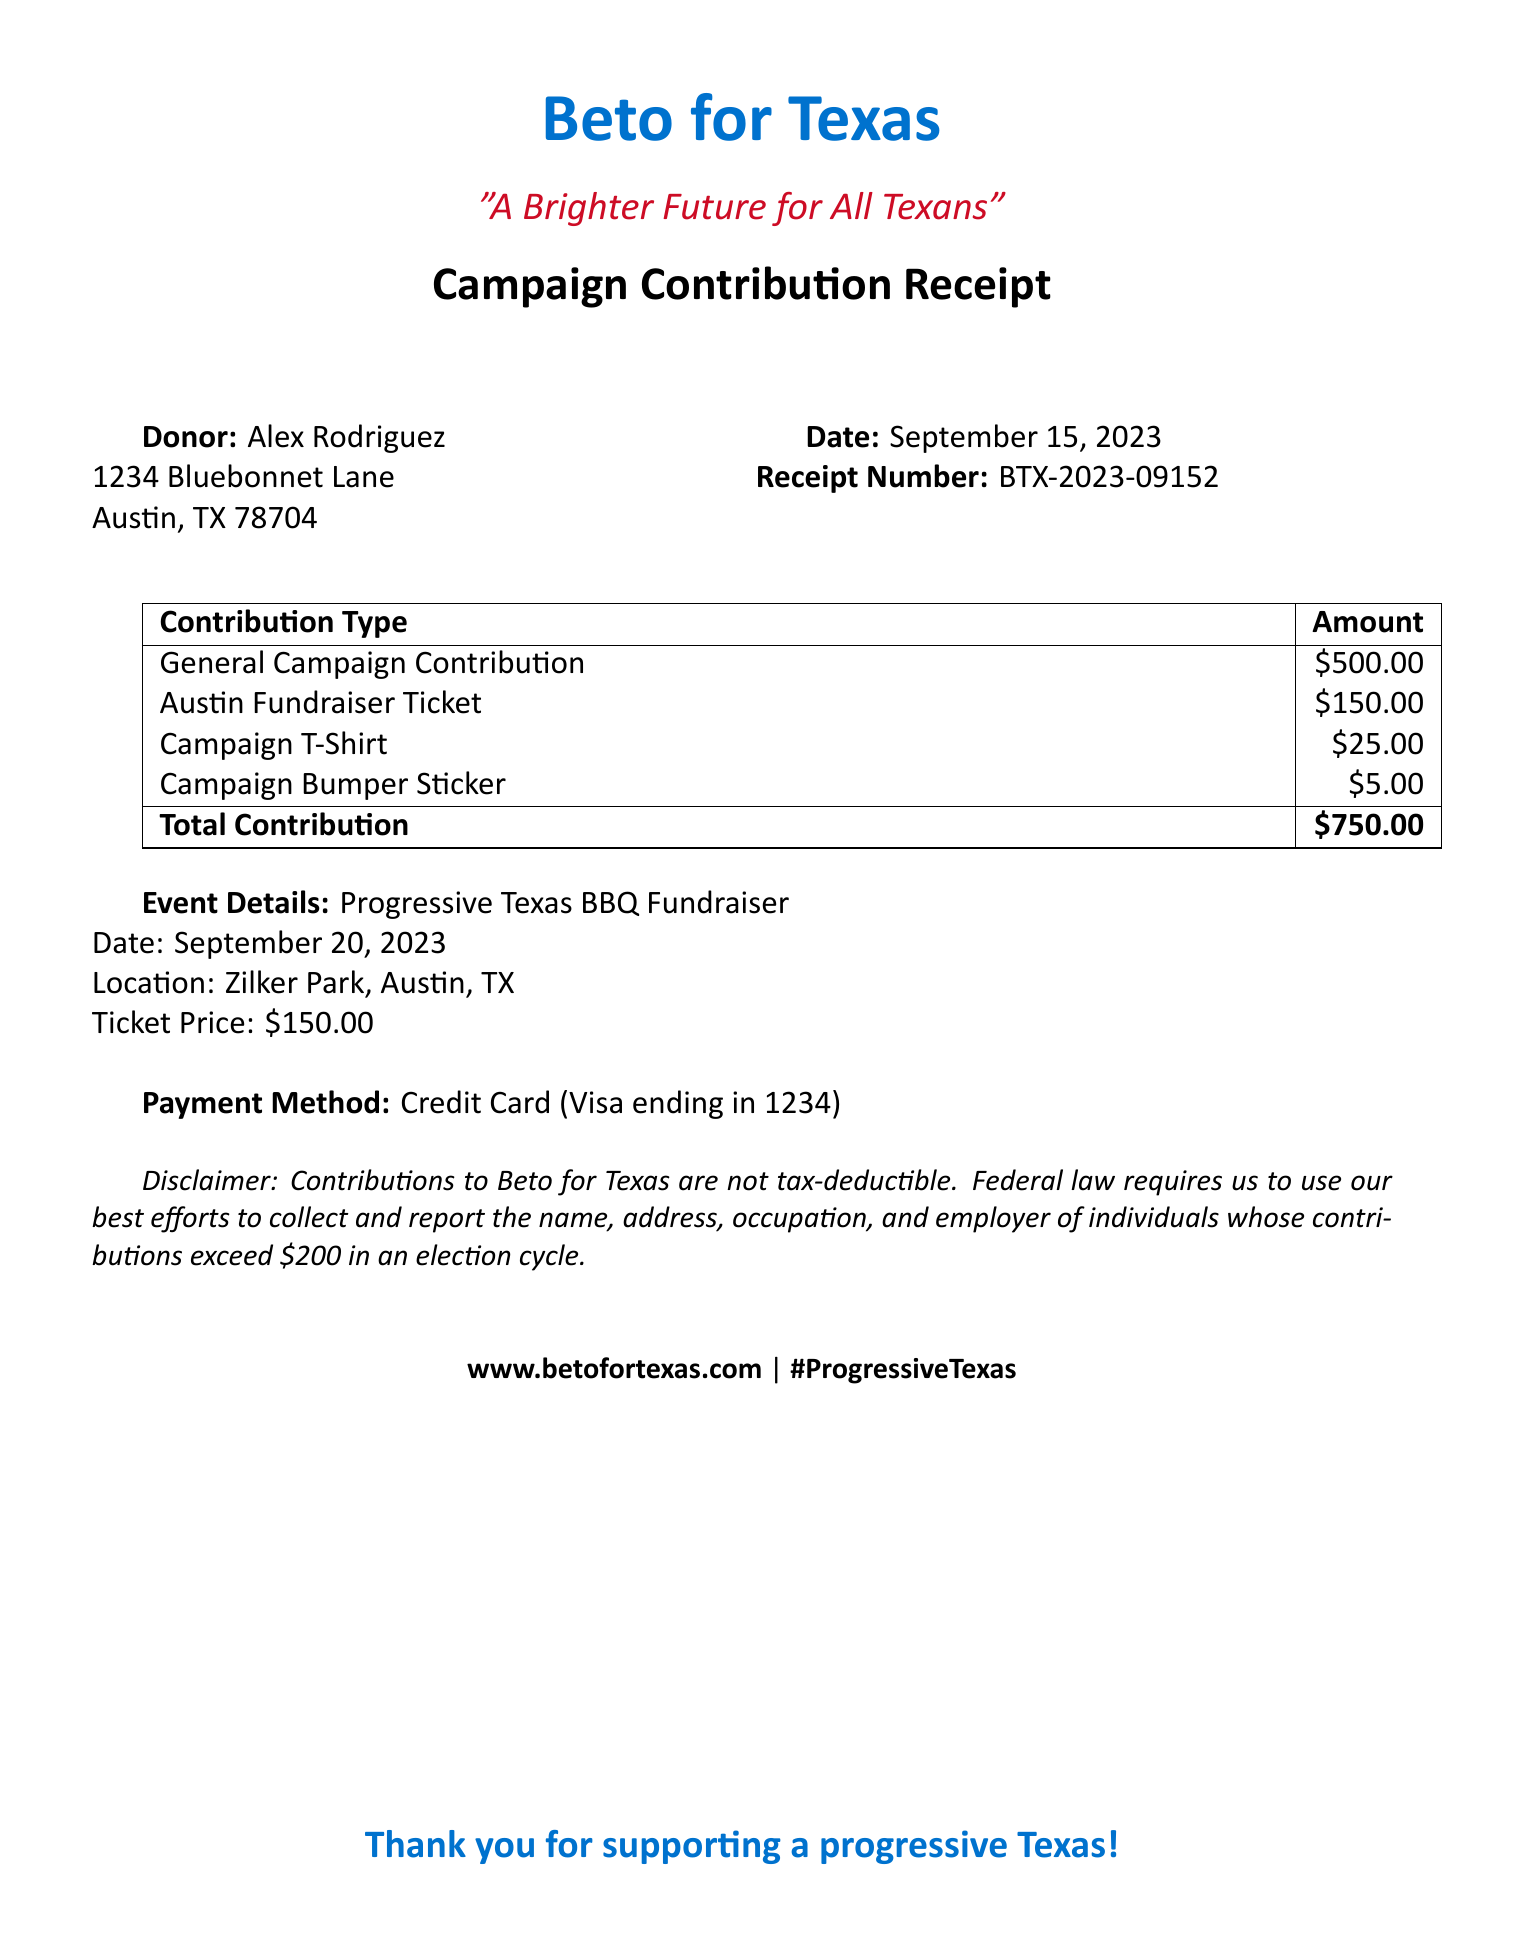What is the donor's name? The donor's name is listed at the top of the receipt, which is Alex Rodriguez.
Answer: Alex Rodriguez What is the total contribution amount? The total contribution is clearly stated at the bottom of the itemized list, which amounts to $750.00.
Answer: $750.00 When was the receipt issued? The date of the receipt is mentioned near the top of the document as September 15, 2023.
Answer: September 15, 2023 What is the ticket price for the Progressive Texas BBQ Fundraiser? The ticket price for the event is specified as $150.00.
Answer: $150.00 What is the location of the event? The location of the fundraiser is provided as Zilker Park, Austin, TX.
Answer: Zilker Park, Austin, TX How much did the campaign bumper sticker cost? The cost of the campaign bumper sticker is indicated in the table as $5.00.
Answer: $5.00 What payment method was used? The payment method is mentioned at the bottom, specifying it was a credit card with Visa.
Answer: Credit Card (Visa ending in 1234) What type of event is listed? The event type is clearly tagged as a Progressive Texas BBQ Fundraiser.
Answer: Progressive Texas BBQ Fundraiser What does the disclaimer say about contributions? The disclaimer notes that contributions to Beto for Texas are not tax-deductible.
Answer: Not tax-deductible 